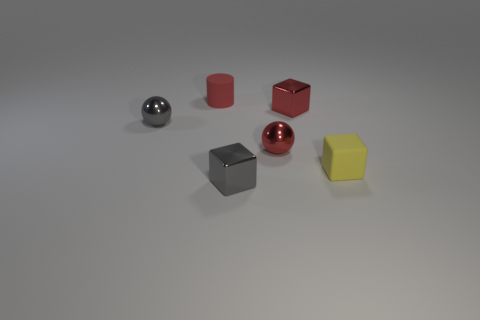There is a tiny rubber object to the right of the small red rubber object; does it have the same shape as the small red rubber thing?
Provide a succinct answer. No. There is a small sphere that is left of the cylinder; what material is it?
Offer a very short reply. Metal. How many gray metal objects are the same shape as the yellow object?
Offer a very short reply. 1. What material is the red object that is in front of the metal block to the right of the tiny gray shiny cube?
Provide a short and direct response. Metal. Are there any large cyan objects made of the same material as the red cylinder?
Your answer should be very brief. No. The yellow thing is what shape?
Give a very brief answer. Cube. How many gray balls are there?
Provide a succinct answer. 1. What is the color of the small metal cube that is in front of the small gray metal object that is to the left of the small red rubber cylinder?
Ensure brevity in your answer.  Gray. What color is the matte cube that is the same size as the gray sphere?
Give a very brief answer. Yellow. Is there another small rubber block of the same color as the tiny matte cube?
Your answer should be compact. No. 